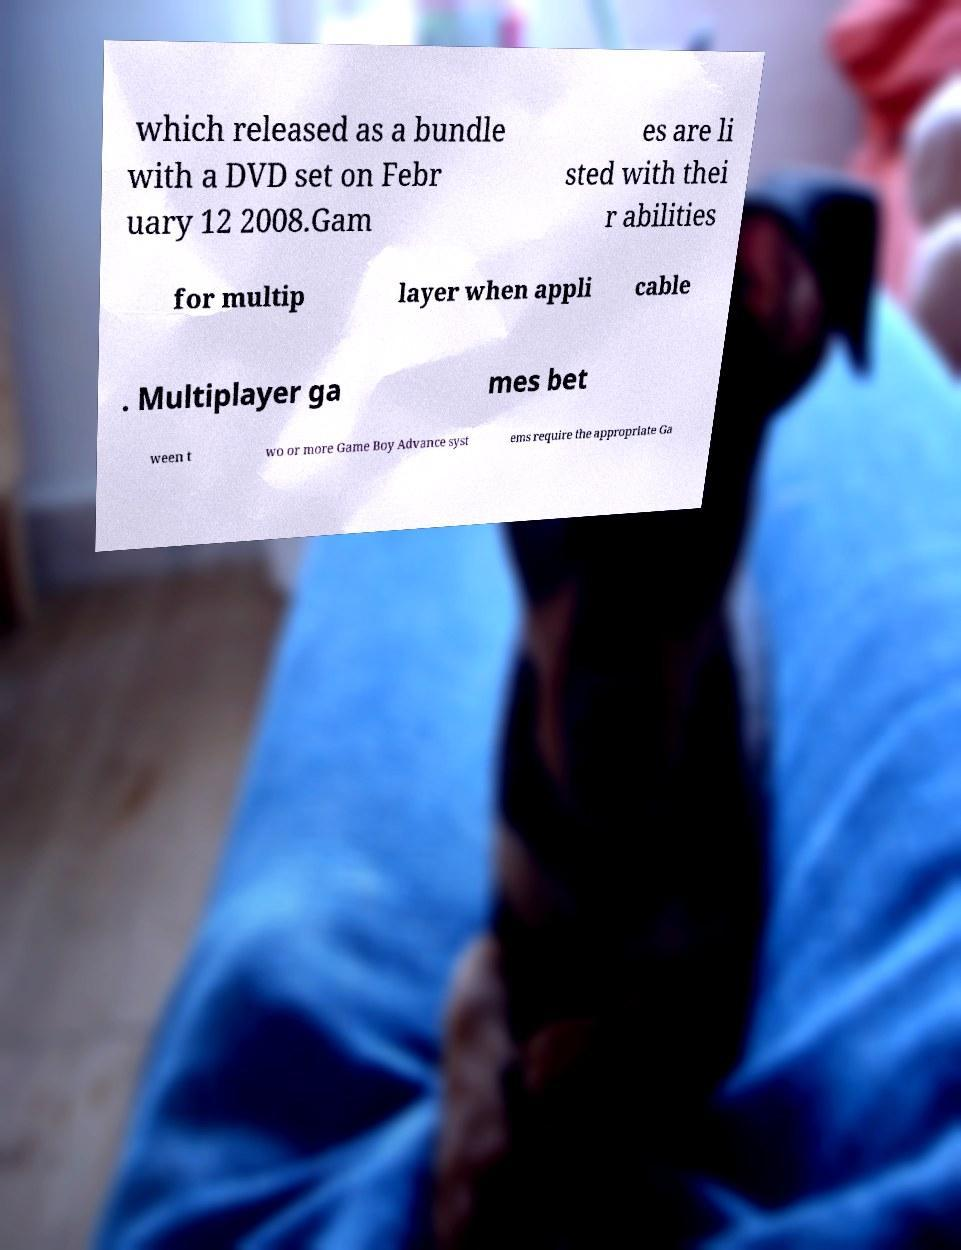There's text embedded in this image that I need extracted. Can you transcribe it verbatim? which released as a bundle with a DVD set on Febr uary 12 2008.Gam es are li sted with thei r abilities for multip layer when appli cable . Multiplayer ga mes bet ween t wo or more Game Boy Advance syst ems require the appropriate Ga 